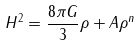<formula> <loc_0><loc_0><loc_500><loc_500>H ^ { 2 } = \frac { 8 \pi G } { 3 } \rho + A \rho ^ { n }</formula> 